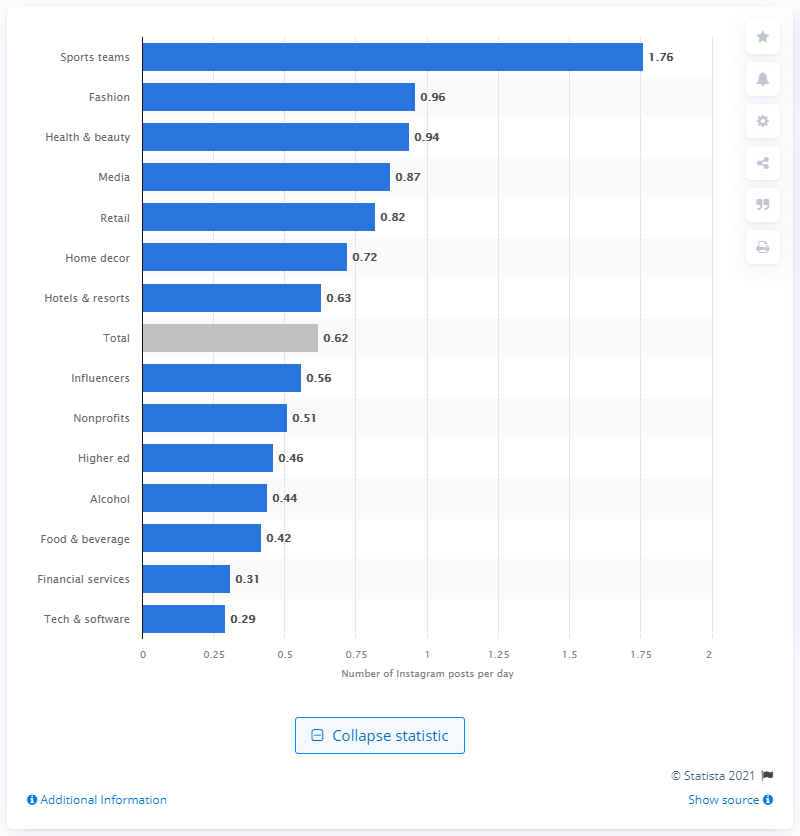Identify some key points in this picture. Sports teams posted an average of 1.76 posts per day on Instagram. 